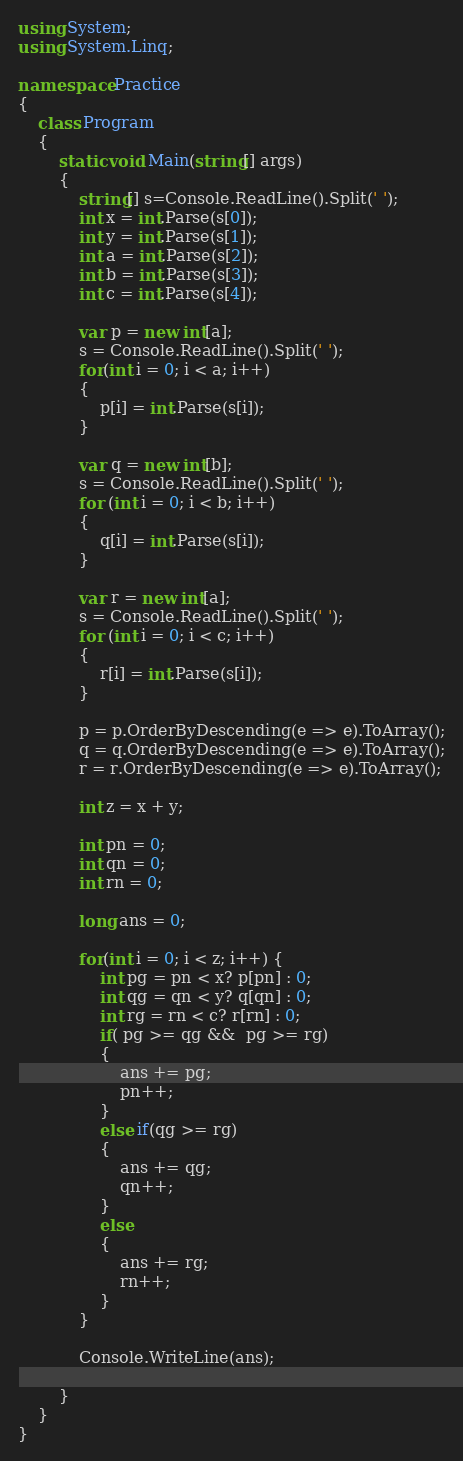Convert code to text. <code><loc_0><loc_0><loc_500><loc_500><_C#_>using System;
using System.Linq;

namespace Practice
{
    class Program
    {
        static void Main(string[] args)
        {
            string[] s=Console.ReadLine().Split(' ');
            int x = int.Parse(s[0]);
            int y = int.Parse(s[1]);
            int a = int.Parse(s[2]);
            int b = int.Parse(s[3]);
            int c = int.Parse(s[4]);

            var p = new int[a];
            s = Console.ReadLine().Split(' ');
            for(int i = 0; i < a; i++)
            {
                p[i] = int.Parse(s[i]);
            }

            var q = new int[b];
            s = Console.ReadLine().Split(' ');
            for (int i = 0; i < b; i++)
            {
                q[i] = int.Parse(s[i]);
            }

            var r = new int[a];
            s = Console.ReadLine().Split(' ');
            for (int i = 0; i < c; i++)
            {
                r[i] = int.Parse(s[i]);
            }

            p = p.OrderByDescending(e => e).ToArray();
            q = q.OrderByDescending(e => e).ToArray();
            r = r.OrderByDescending(e => e).ToArray();

            int z = x + y;

            int pn = 0;
            int qn = 0;
            int rn = 0;

            long ans = 0;

            for(int i = 0; i < z; i++) { 
                int pg = pn < x? p[pn] : 0;
                int qg = qn < y? q[qn] : 0;
                int rg = rn < c? r[rn] : 0;
                if( pg >= qg &&  pg >= rg)
                {
                    ans += pg;
                    pn++;
                }
                else if(qg >= rg)
                {
                    ans += qg;
                    qn++;
                }
                else
                {
                    ans += rg;
                    rn++;
                }
            }

            Console.WriteLine(ans);

        }
    }
}
</code> 